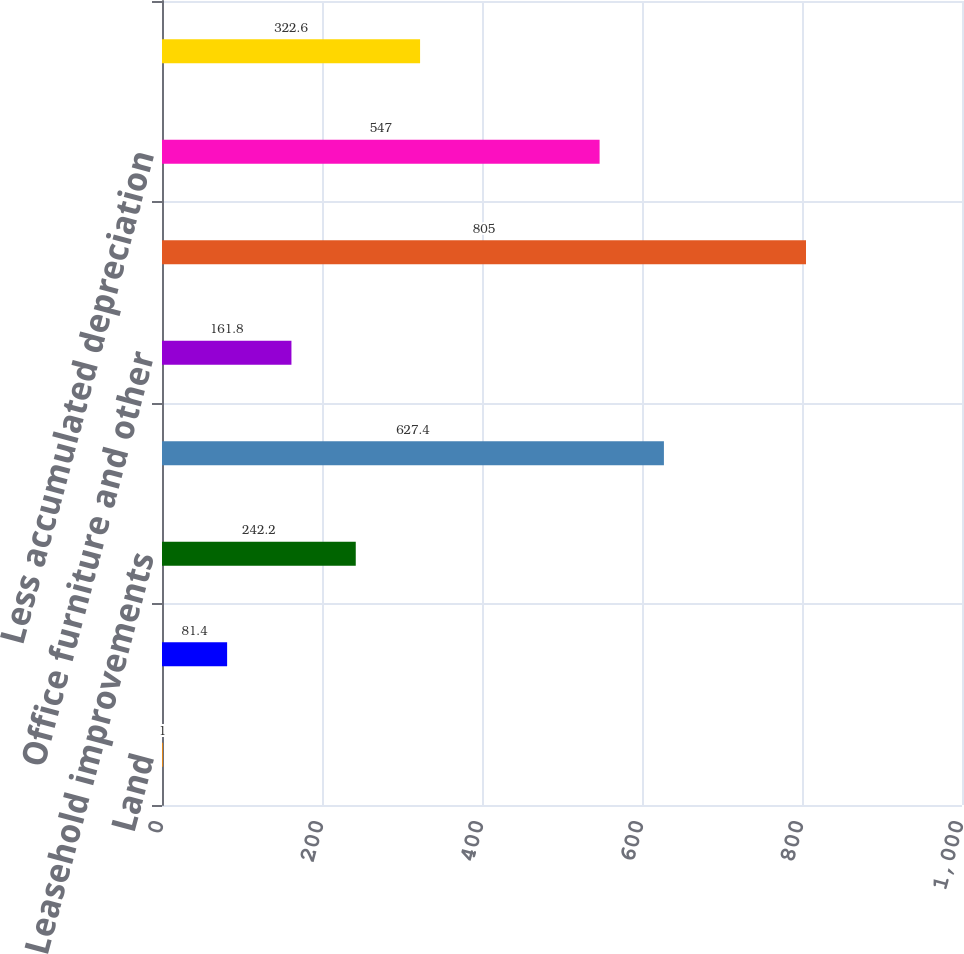Convert chart to OTSL. <chart><loc_0><loc_0><loc_500><loc_500><bar_chart><fcel>Land<fcel>Buildings<fcel>Leasehold improvements<fcel>Computer equipment<fcel>Office furniture and other<fcel>Total cost of property and<fcel>Less accumulated depreciation<fcel>Property and equipment net<nl><fcel>1<fcel>81.4<fcel>242.2<fcel>627.4<fcel>161.8<fcel>805<fcel>547<fcel>322.6<nl></chart> 